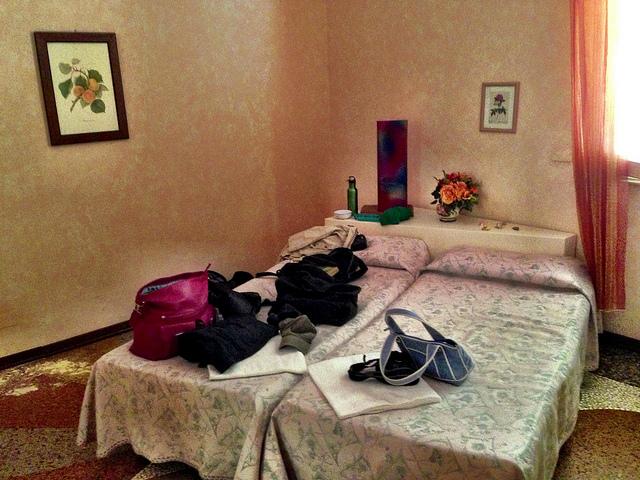Is it a daytime?
Be succinct. Yes. Which room is this?
Concise answer only. Bedroom. Is there a green water bottle in view?
Answer briefly. Yes. 